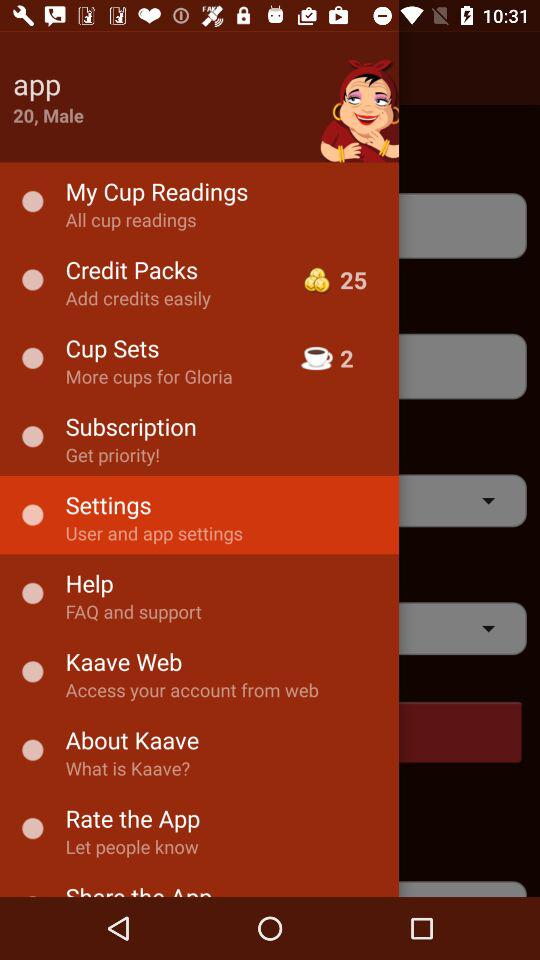How many credits are there in total in "Credit Packs"? There are 25 credits in total in "Credit Packs". 